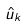<formula> <loc_0><loc_0><loc_500><loc_500>\hat { u } _ { k }</formula> 